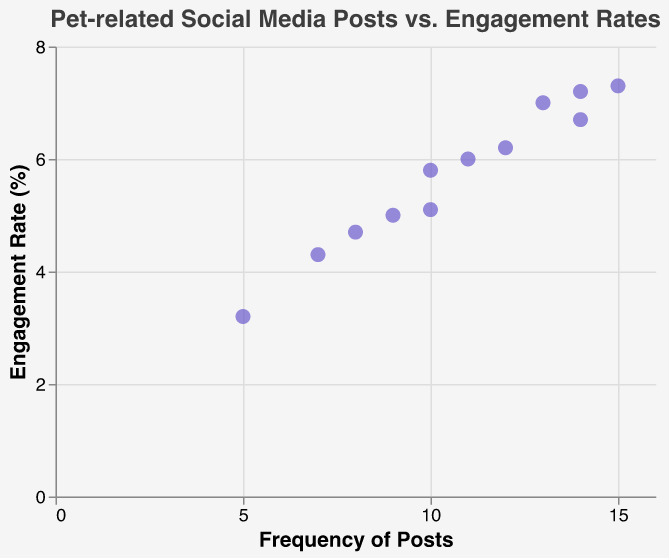What is the title of the scatter plot? The title of the scatter plot is clearly stated at the top of the figure.
Answer: Pet-related Social Media Posts vs. Engagement Rates How many data points are shown in the figure? Each data point corresponds to a month and there are twelve months in the year, hence twelve data points.
Answer: 12 What is the axis range for the frequency of posts? The x-axis shows the frequency of posts and its range can be observed from the lowest to the highest value on the axis. The axis starts from around 5 and ends around 15.
Answer: 5 to 15 Which month had the highest engagement rate and what was the rate? By examining the tooltip or the highest point on the y-axis, we see that October has the highest engagement rate.
Answer: October, 7.3% What is the engagement rate for the month with the lowest frequency of posts? The month with the lowest frequency of posts is January with 5 posts. The corresponding engagement rate is noted alongside the January data point.
Answer: 3.2% What's the average engagement rate for months with more than 10 posts? The months with more than 10 posts are June, July, August, October, November, and December. Their engagement rates are 6.2, 6.7, 6.0, 7.3, 7.0, and 7.2 respectively. The average is computed by summing these values and dividing by the number of months: (6.2+6.7+6.0+7.3+7.0+7.2)/6.
Answer: 6.73 Did engagement rates increase as the frequency of posts increased? By observing the overall trend of the scatter plot, we can see that the engagement rates generally increase with an increasing frequency of posts.
Answer: Yes What is the difference in engagement rate between the month with the highest and the month with the lowest frequency of posts? The month with the highest frequency of posts is October (15) and the lowest is January (5). The engagement rates for these months are 7.3% and 3.2% respectively. The difference is calculated as 7.3 - 3.2.
Answer: 4.1% What was the engagement rate for the month of April? By locating April on the plot, the corresponding engagement rate can be seen.
Answer: 5.1% Which month had a similar frequency of posts to December but lower engagement rate? December's frequency of posts is 14. We look for another month with a similar number of posts and compare their engagement rates. July also had 14 posts but a lower engagement rate.
Answer: July 